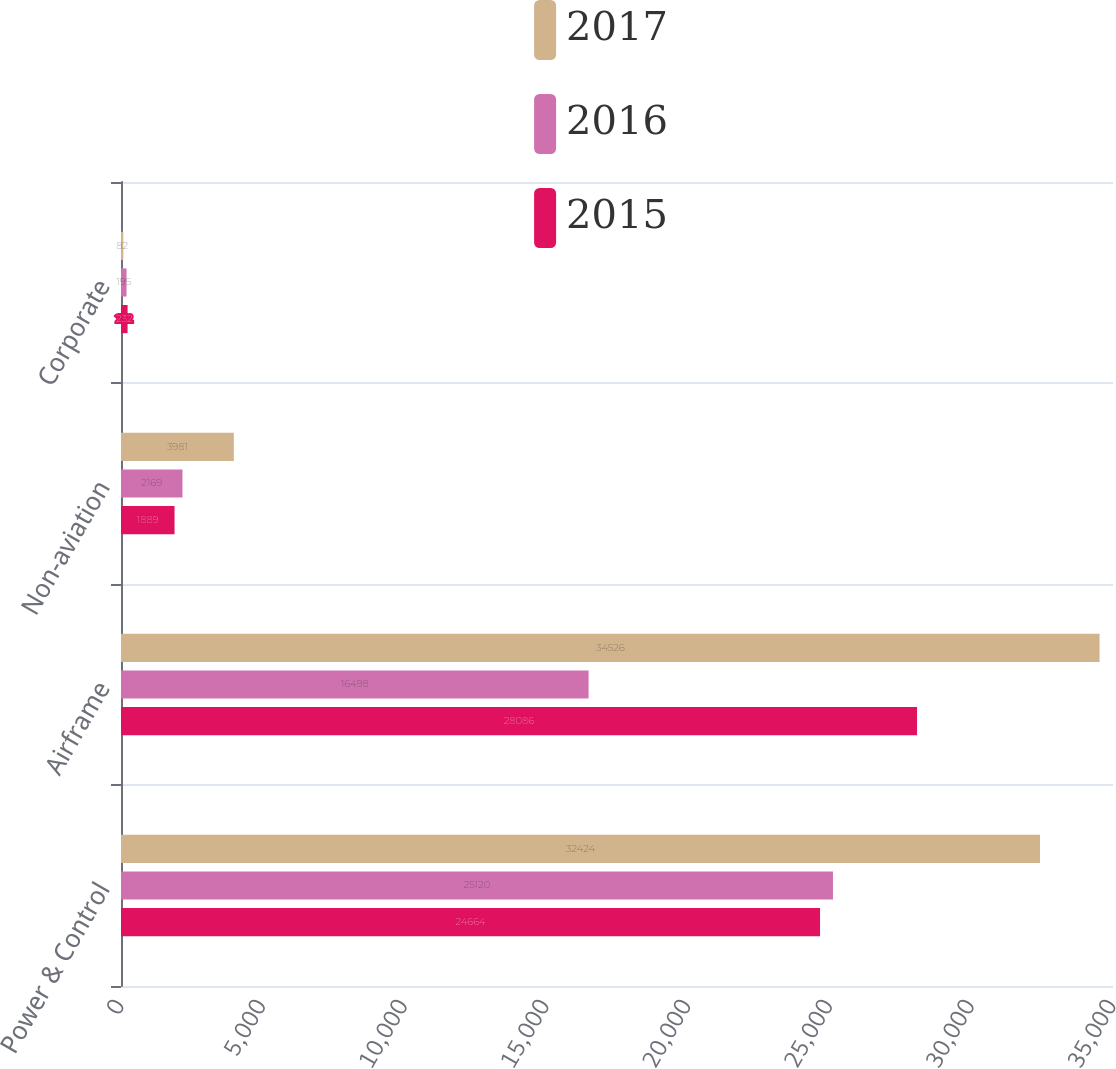<chart> <loc_0><loc_0><loc_500><loc_500><stacked_bar_chart><ecel><fcel>Power & Control<fcel>Airframe<fcel>Non-aviation<fcel>Corporate<nl><fcel>2017<fcel>32424<fcel>34526<fcel>3981<fcel>82<nl><fcel>2016<fcel>25120<fcel>16498<fcel>2169<fcel>195<nl><fcel>2015<fcel>24664<fcel>28086<fcel>1889<fcel>232<nl></chart> 